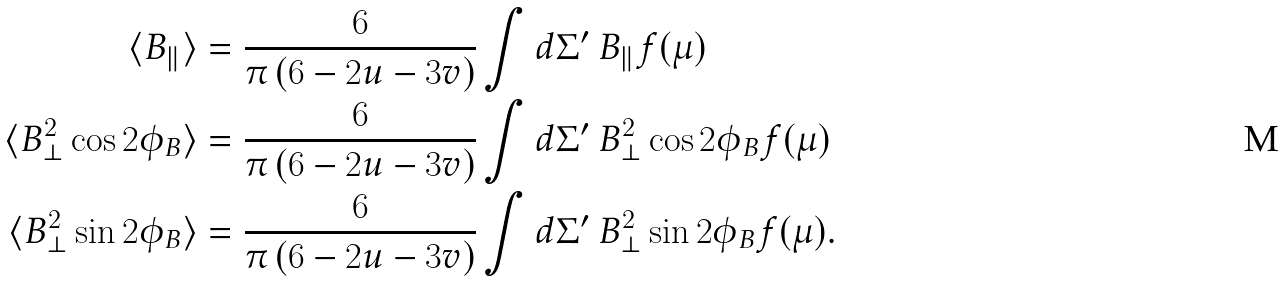<formula> <loc_0><loc_0><loc_500><loc_500>\langle B _ { \| } \rangle & = \frac { 6 } { \pi \left ( 6 - 2 u - 3 v \right ) } \int d \Sigma ^ { \prime } \ B _ { \| } f ( \mu ) \\ \langle B _ { \perp } ^ { 2 } \cos { 2 \phi _ { B } } \rangle & = \frac { 6 } { \pi \left ( 6 - 2 u - 3 v \right ) } \int d \Sigma ^ { \prime } \ B ^ { 2 } _ { \perp } \cos { 2 \phi _ { B } } f ( \mu ) \\ \langle B _ { \perp } ^ { 2 } \sin { 2 \phi _ { B } } \rangle & = \frac { 6 } { \pi \left ( 6 - 2 u - 3 v \right ) } \int d \Sigma ^ { \prime } \ B ^ { 2 } _ { \perp } \sin { 2 \phi _ { B } } f ( \mu ) .</formula> 